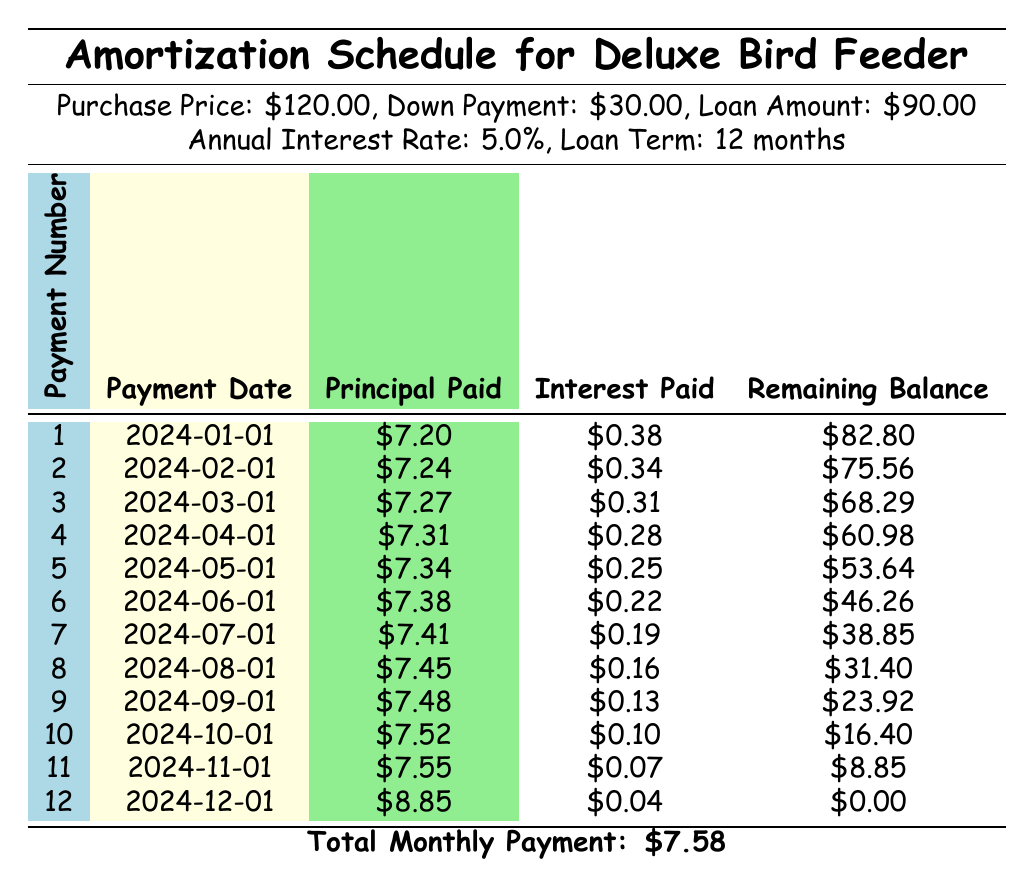What is the total monthly payment for the Deluxe Bird Feeder? The total monthly payment is listed in the last row of the table, which states the amount is \$7.58.
Answer: 7.58 How much principal was paid in the first payment? The first payment row indicates that the principal paid was \$7.20.
Answer: 7.20 What is the interest paid for the 6th payment? By looking at the 6th payment row, it is shown that the interest paid was \$0.22.
Answer: 0.22 Is the remaining balance after the last payment zero? The last payment row shows that the remaining balance is indeed \$0.00, which confirms that it is zero after the last payment.
Answer: Yes What was the total principal paid over all the payments? To find the total principal paid, we sum the principal paid for all 12 payments: 7.20 + 7.24 + 7.27 + 7.31 + 7.34 + 7.38 + 7.41 + 7.45 + 7.48 + 7.52 + 7.55 + 8.85 = 90.00, which checks out to match the loan amount.
Answer: 90.00 What is the difference in principal paid between the first and the last payments? The principal paid in the first payment is \$7.20 and in the last payment is \$8.85, so the difference is 8.85 - 7.20 = \$1.65.
Answer: 1.65 How much interest is paid in total for the loan? The total interest paid can be calculated by summing up the interest payments for all 12 months: 0.38 + 0.34 + 0.31 + 0.28 + 0.25 + 0.22 + 0.19 + 0.16 + 0.13 + 0.10 + 0.07 + 0.04 = 2.47.
Answer: 2.47 What is the average principal paid per month? To get the average principal paid per month, we divide the total principal paid of \$90.00 by the total number of payments (12): 90 / 12 = 7.50.
Answer: 7.50 Was there ever a month where more than \$8 in principal was paid? Looking at the principal paid column, the highest amount recorded was \$8.85 in the last payment, confirming that an amount over \$8 was indeed paid.
Answer: Yes 